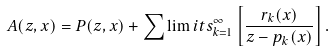Convert formula to latex. <formula><loc_0><loc_0><loc_500><loc_500>A ( z , x ) = P ( z , x ) + \sum \lim i t s _ { k = 1 } ^ { \infty } \left [ \frac { r _ { k } ( x ) } { z - p _ { k } ( x ) } \right ] .</formula> 